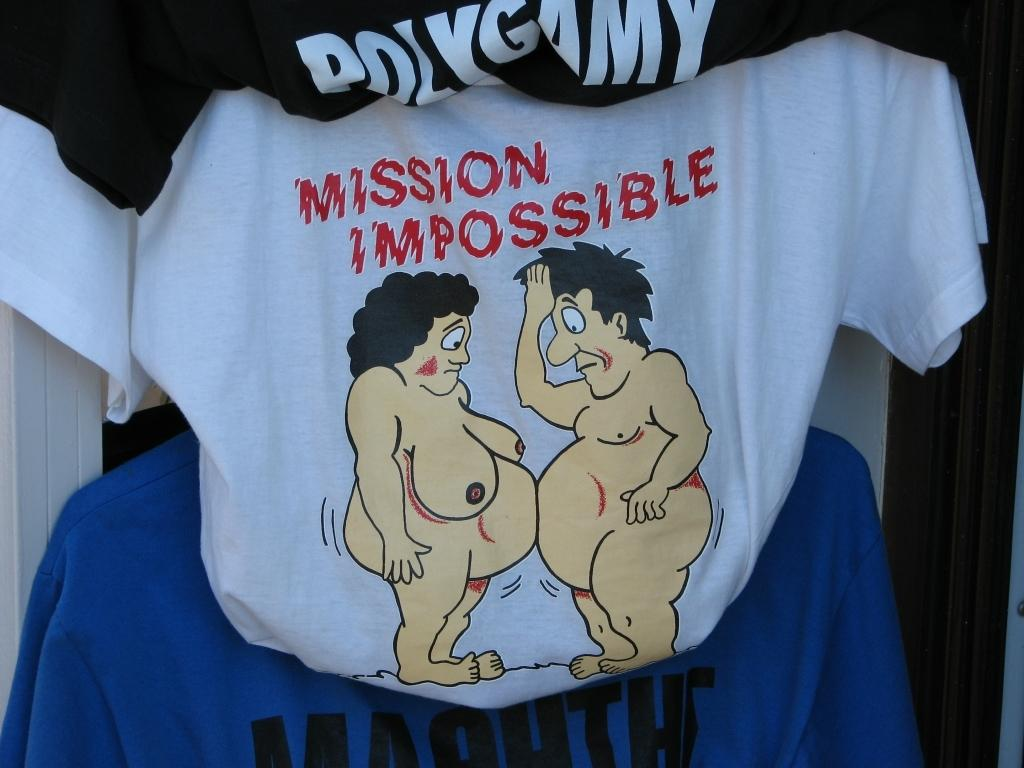<image>
Offer a succinct explanation of the picture presented. The t-shirt is captioned Mission Impossible and features a naked fat couple. 